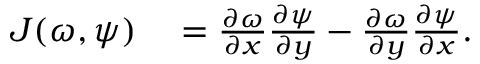<formula> <loc_0><loc_0><loc_500><loc_500>\begin{array} { r l } { J ( \omega , \psi ) } & = \frac { \partial \omega } { \partial x } \frac { \partial \psi } { \partial y } - \frac { \partial \omega } { \partial y } \frac { \partial \psi } { \partial x } . } \end{array}</formula> 